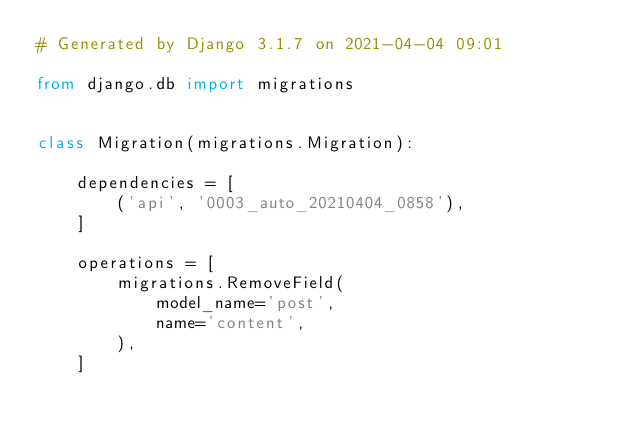<code> <loc_0><loc_0><loc_500><loc_500><_Python_># Generated by Django 3.1.7 on 2021-04-04 09:01

from django.db import migrations


class Migration(migrations.Migration):

    dependencies = [
        ('api', '0003_auto_20210404_0858'),
    ]

    operations = [
        migrations.RemoveField(
            model_name='post',
            name='content',
        ),
    ]
</code> 